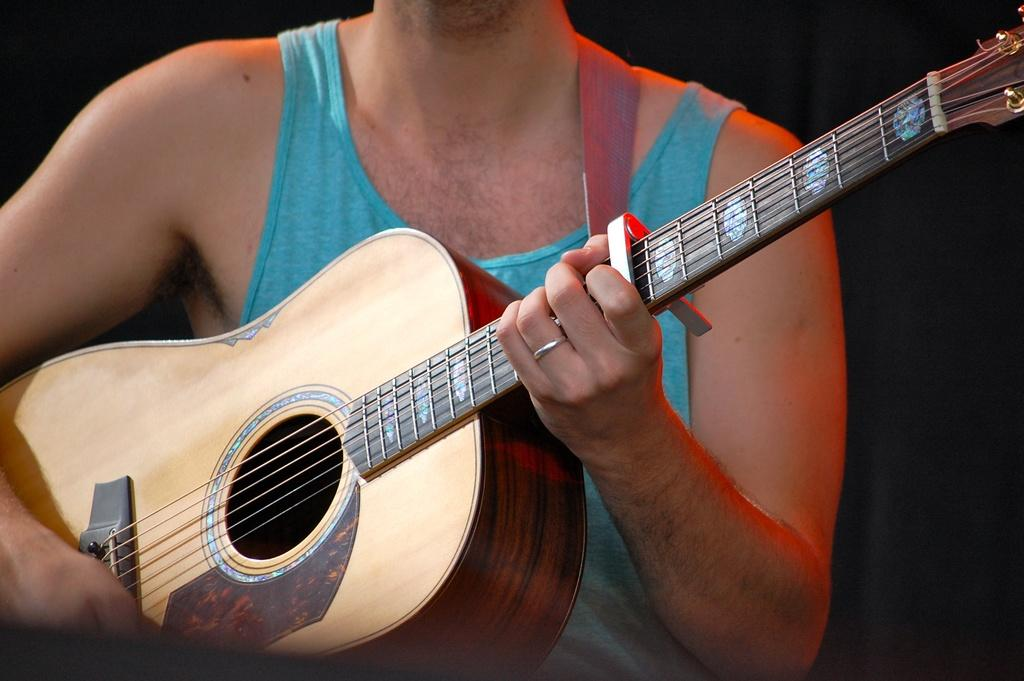What is the main subject of the image? There is a person in the image. What type of clothing is the person wearing? The person is wearing a tank top. What object is the person holding in their hands? The person is holding a guitar in their hands. What type of ship can be seen in the background of the image? There is no ship visible in the image; it only features a person wearing a tank top and holding a guitar. 